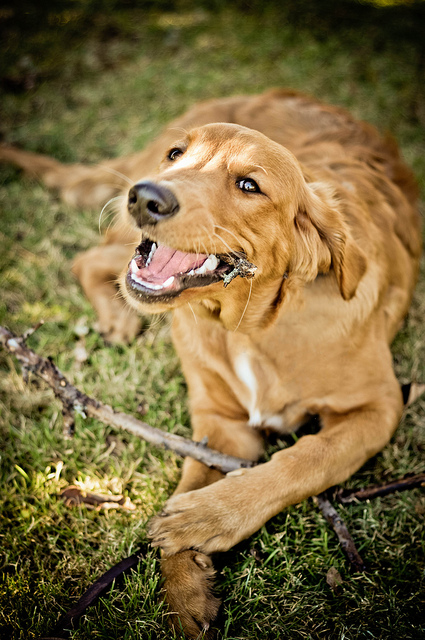<image>Who is a bad dog? It's ambiguous to tell who is the bad dog. Who is a bad dog? I don't know who is a bad dog. It is not clear from the given answers. 